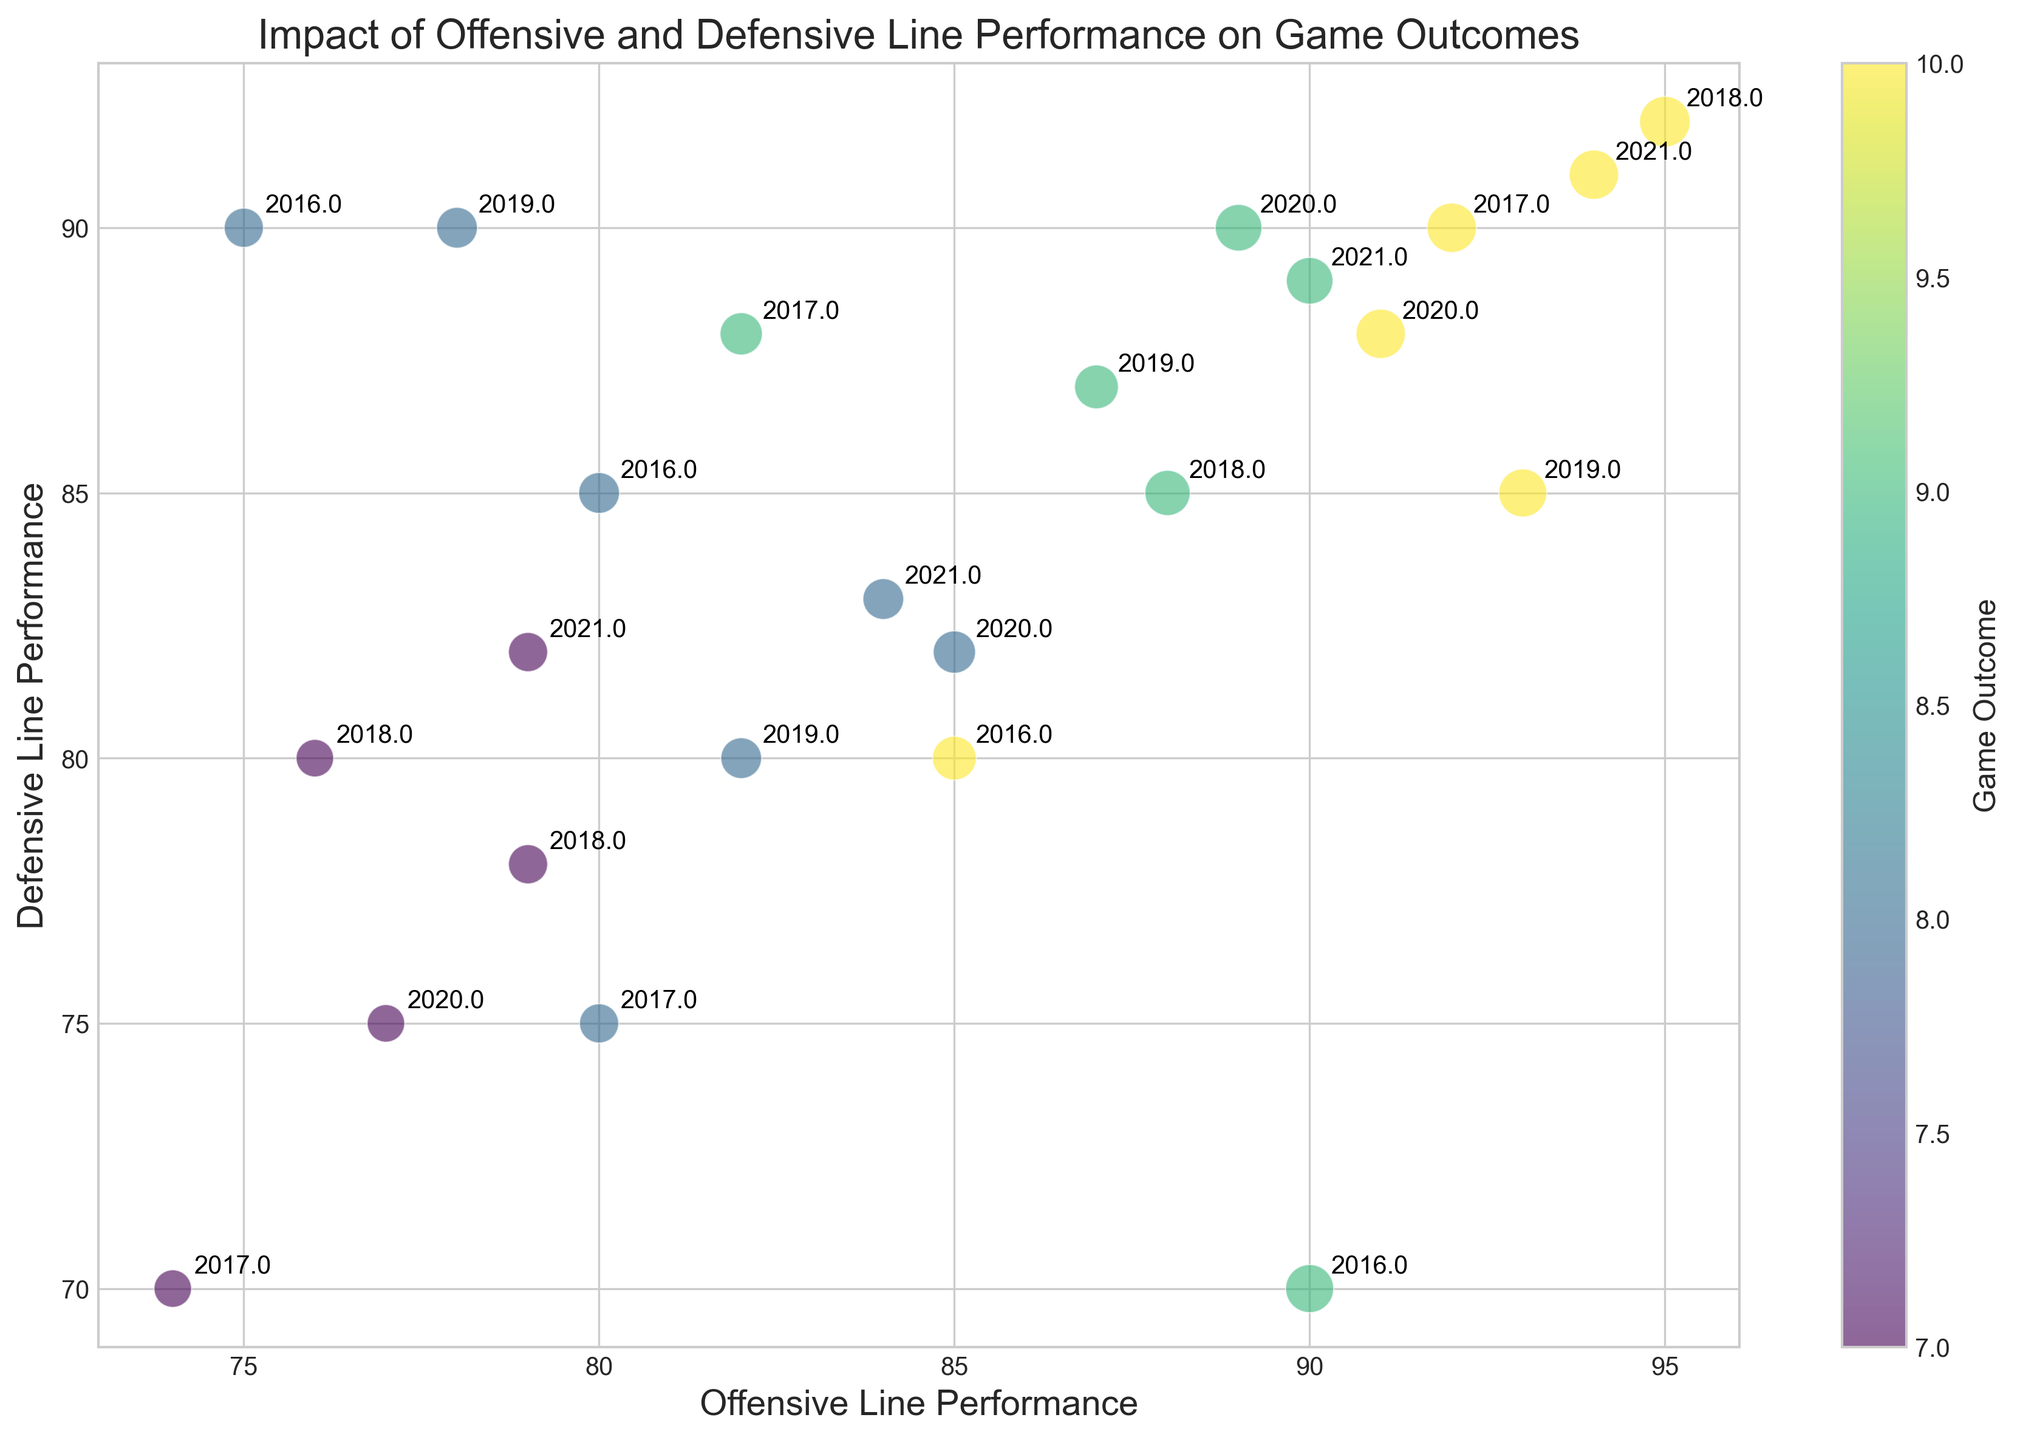What's the overall trend of game outcomes in relation to Offensive and Defensive Line Performance? To determine the overall trend, observe the color gradient in the plot (which represents game outcomes). Higher scores in both Offensive and Defensive Line Performance tend to have darker colors, indicating better game outcomes. Therefore, the trend shows that teams with better line performances generally have better outcomes.
Answer: Teams with better line performances have better outcomes Which season has the best combined Offensive and Defensive Line Performance, and what is the Game Outcome for that season? The best combined performance would be the highest sum of Offensive Line Performance and Defensive Line Performance. For 2018 with scores of Offensive Line Performance (95) and Defensive Line Performance (92), the sum is 187. The Game Outcome for this season is represented by the darkest bubble which corresponds to 10.
Answer: 2018, Game Outcome: 10 Comparing 2017 and 2019, which year had better Defensive Line Performance overall? To compare Defensive Line Performance, look for the average values of all data points for each season. In 2017, the Defensive Line Performance values are 88, 70, 90, and 75. In 2019, the values are 87, 90, 85, and 80. Sum and average for 2017: (88 + 70 + 90 + 75)/4 = 80.75. Sum and average for 2019: (87 + 90 + 85 + 80)/4 = 85.5.
Answer: 2019 Which year has the season with the highest game outcome, and what is the offensive and defensive line performance for that season? The highest game outcome is represented by the darkest bubble. Check the text labels on the darkest bubble to identify the year and its offensive and defensive line performance values. The highest game outcome is 10 in years 2016 (with scores 85 and 80), 2017 (with scores 92 and 90), 2018 (with scores 95 and 92), 2019 (with scores 93 and 85), 2020 (with scores 91 and 88), and 2021 (with scores 94 and 91).
Answer: 2017, 2018, 2019, 2020, 2021 What are the differences in size between the smallest and largest bubbles, and which seasons do these sizes represent? The smallest bubble size is 1.1, while the largest is 2.0. Examine the seasons attached to these sizes: the smallest bubbles (1.1) are in 2017, 2018, and 2020, and the largest bubble (2.0) is in 2018. The difference in size is calculated as 2.0 - 1.1 = 0.9.
Answer: Smallest bubble in 2017, 2018, 2020 (Size: 1.1); Largest bubble in 2018 (Size: 2.0); Difference: 0.9 